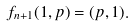<formula> <loc_0><loc_0><loc_500><loc_500>f _ { n + 1 } ( 1 , p ) = ( p , 1 ) .</formula> 